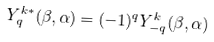Convert formula to latex. <formula><loc_0><loc_0><loc_500><loc_500>Y ^ { k * } _ { q } ( \beta , \alpha ) = ( - 1 ) ^ { q } Y ^ { k } _ { - q } ( \beta , \alpha )</formula> 